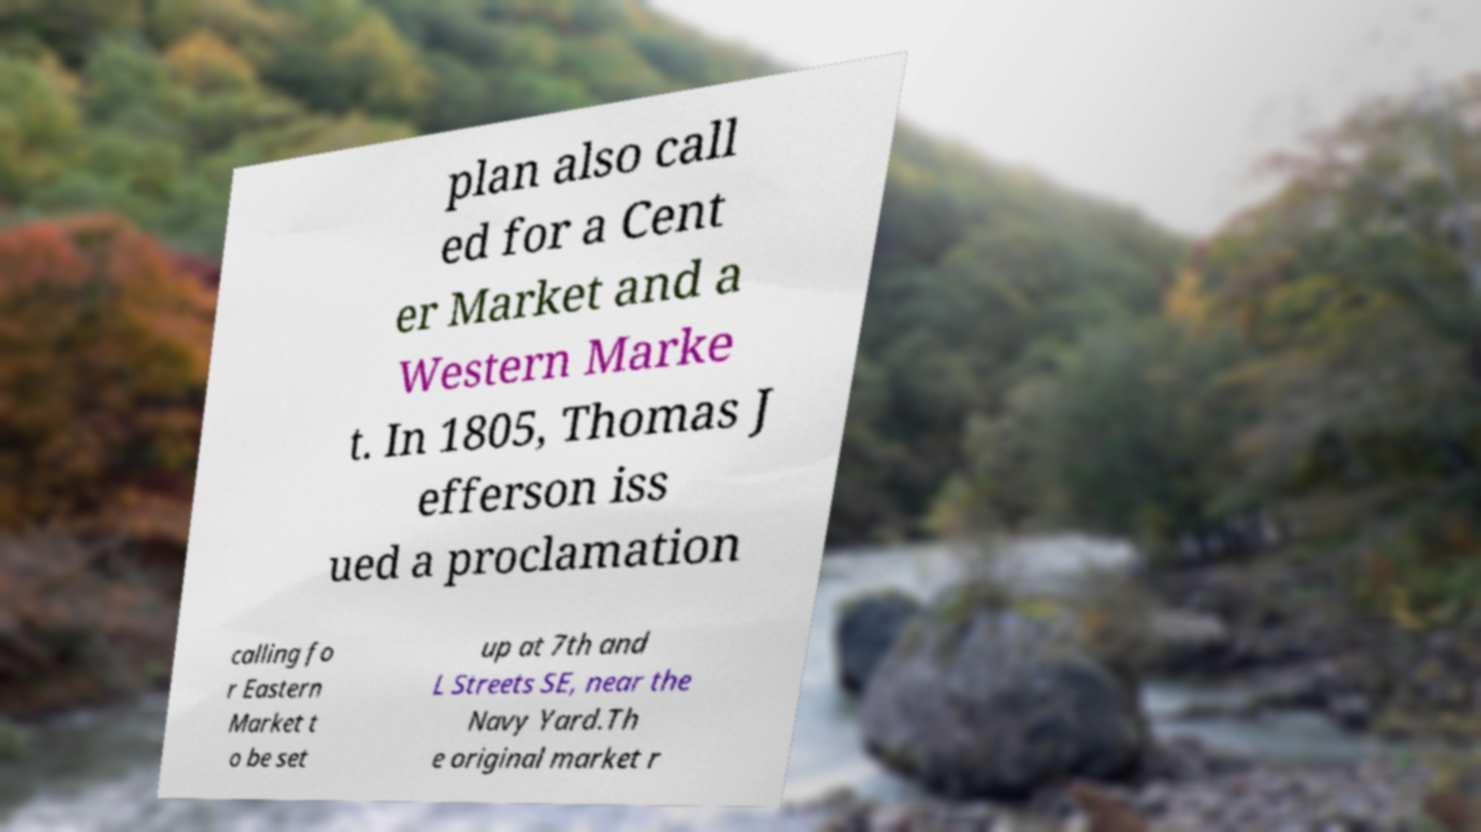Could you assist in decoding the text presented in this image and type it out clearly? plan also call ed for a Cent er Market and a Western Marke t. In 1805, Thomas J efferson iss ued a proclamation calling fo r Eastern Market t o be set up at 7th and L Streets SE, near the Navy Yard.Th e original market r 